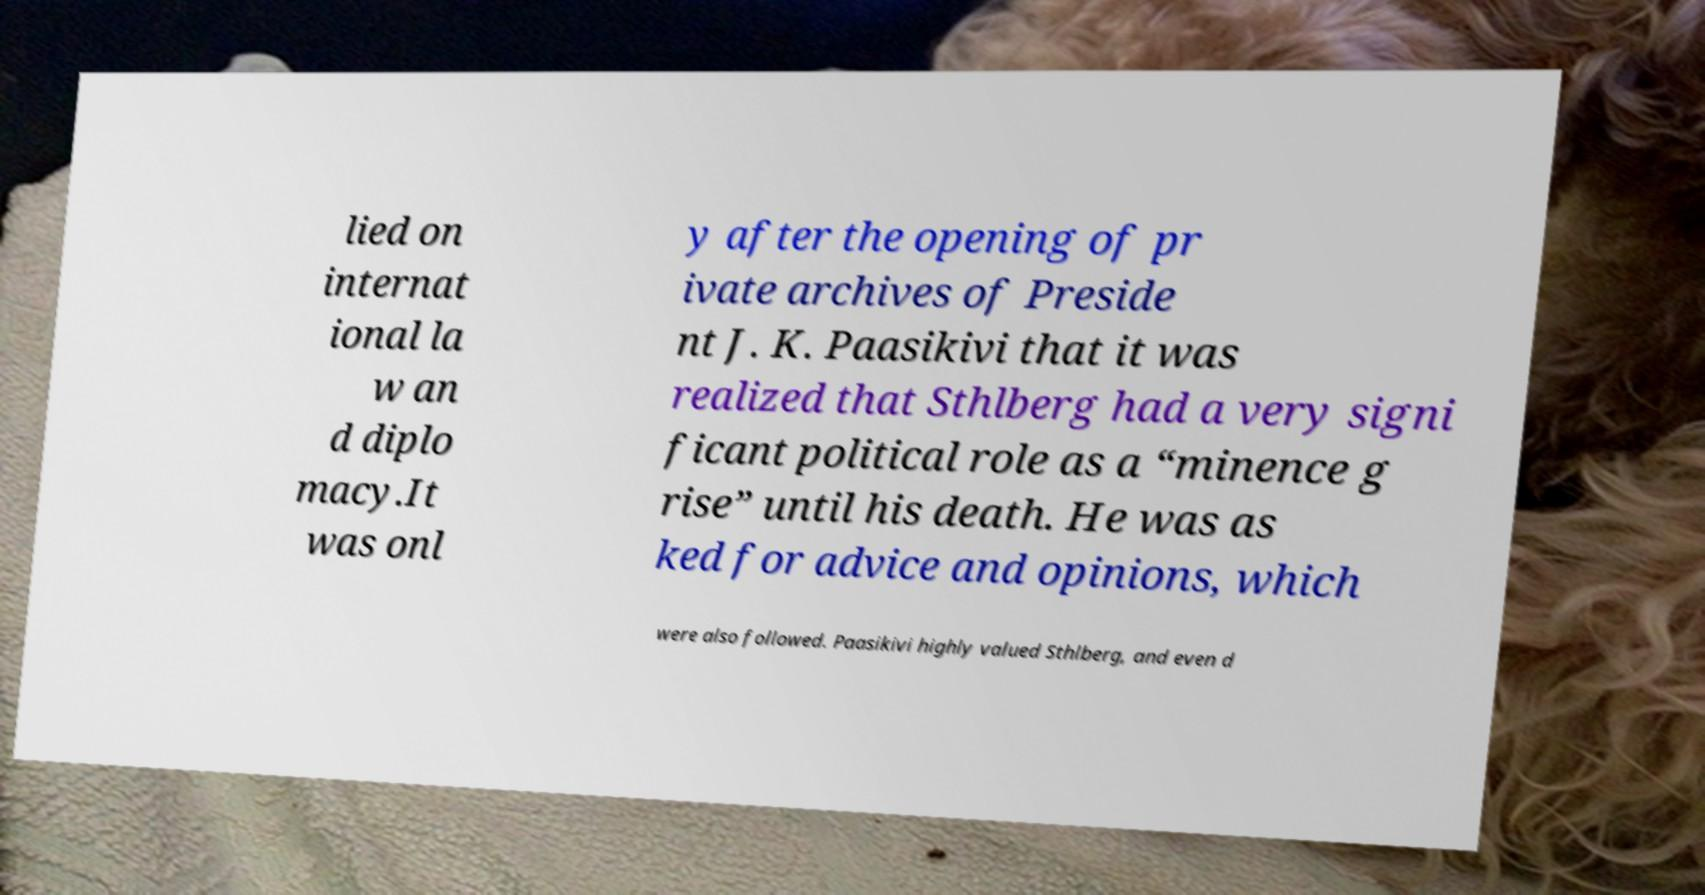For documentation purposes, I need the text within this image transcribed. Could you provide that? lied on internat ional la w an d diplo macy.It was onl y after the opening of pr ivate archives of Preside nt J. K. Paasikivi that it was realized that Sthlberg had a very signi ficant political role as a “minence g rise” until his death. He was as ked for advice and opinions, which were also followed. Paasikivi highly valued Sthlberg, and even d 